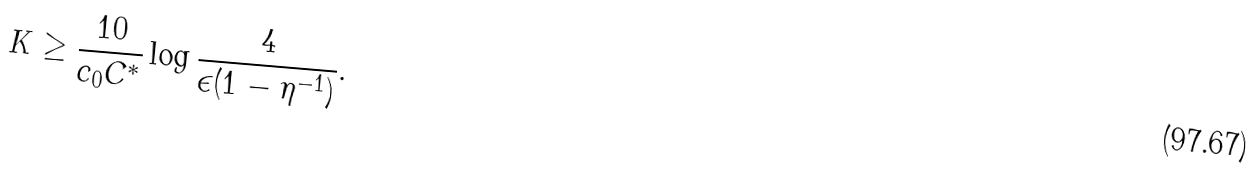<formula> <loc_0><loc_0><loc_500><loc_500>K \geq \frac { 1 0 } { c _ { 0 } C ^ { * } } \log \frac { 4 } { \epsilon ( 1 - \eta ^ { - 1 } ) } .</formula> 